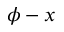<formula> <loc_0><loc_0><loc_500><loc_500>\phi - x</formula> 